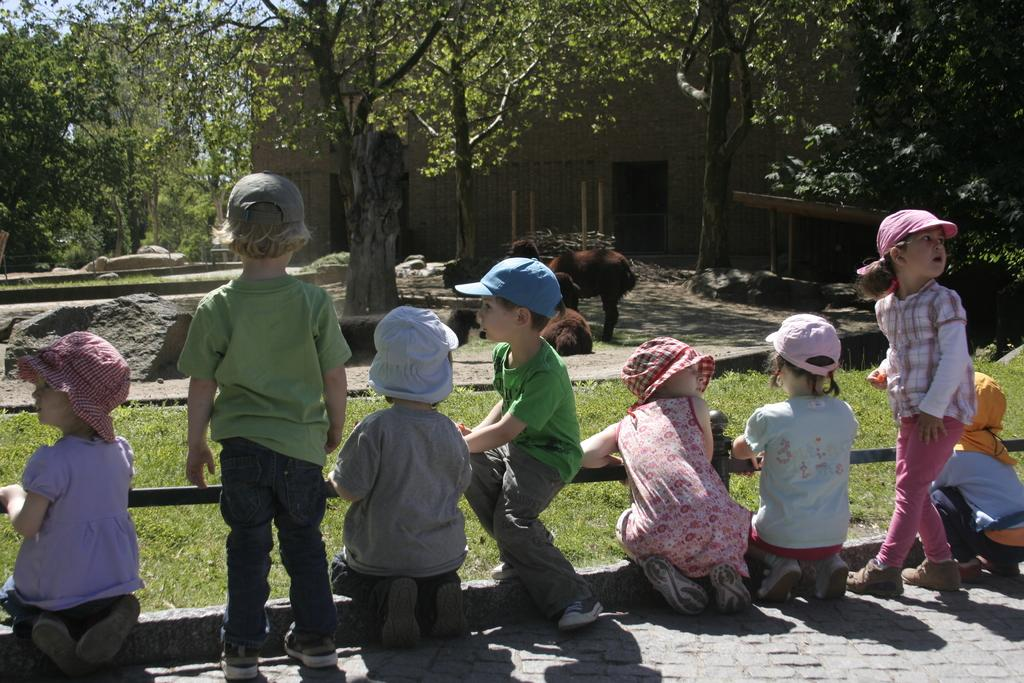How many people are visible on the ground in the image? There are many persons on the ground in the image. What type of vegetation can be seen in the background of the image? There is grass in the background of the image. What other natural elements are present in the background of the image? There are rocks and trees in the background of the image. What type of structure is visible in the background of the image? There is a building in the background of the image. What type of locket is being worn by the animals in the image? There are no animals wearing a locket in the image; the animals are in the background and not wearing any accessories. 